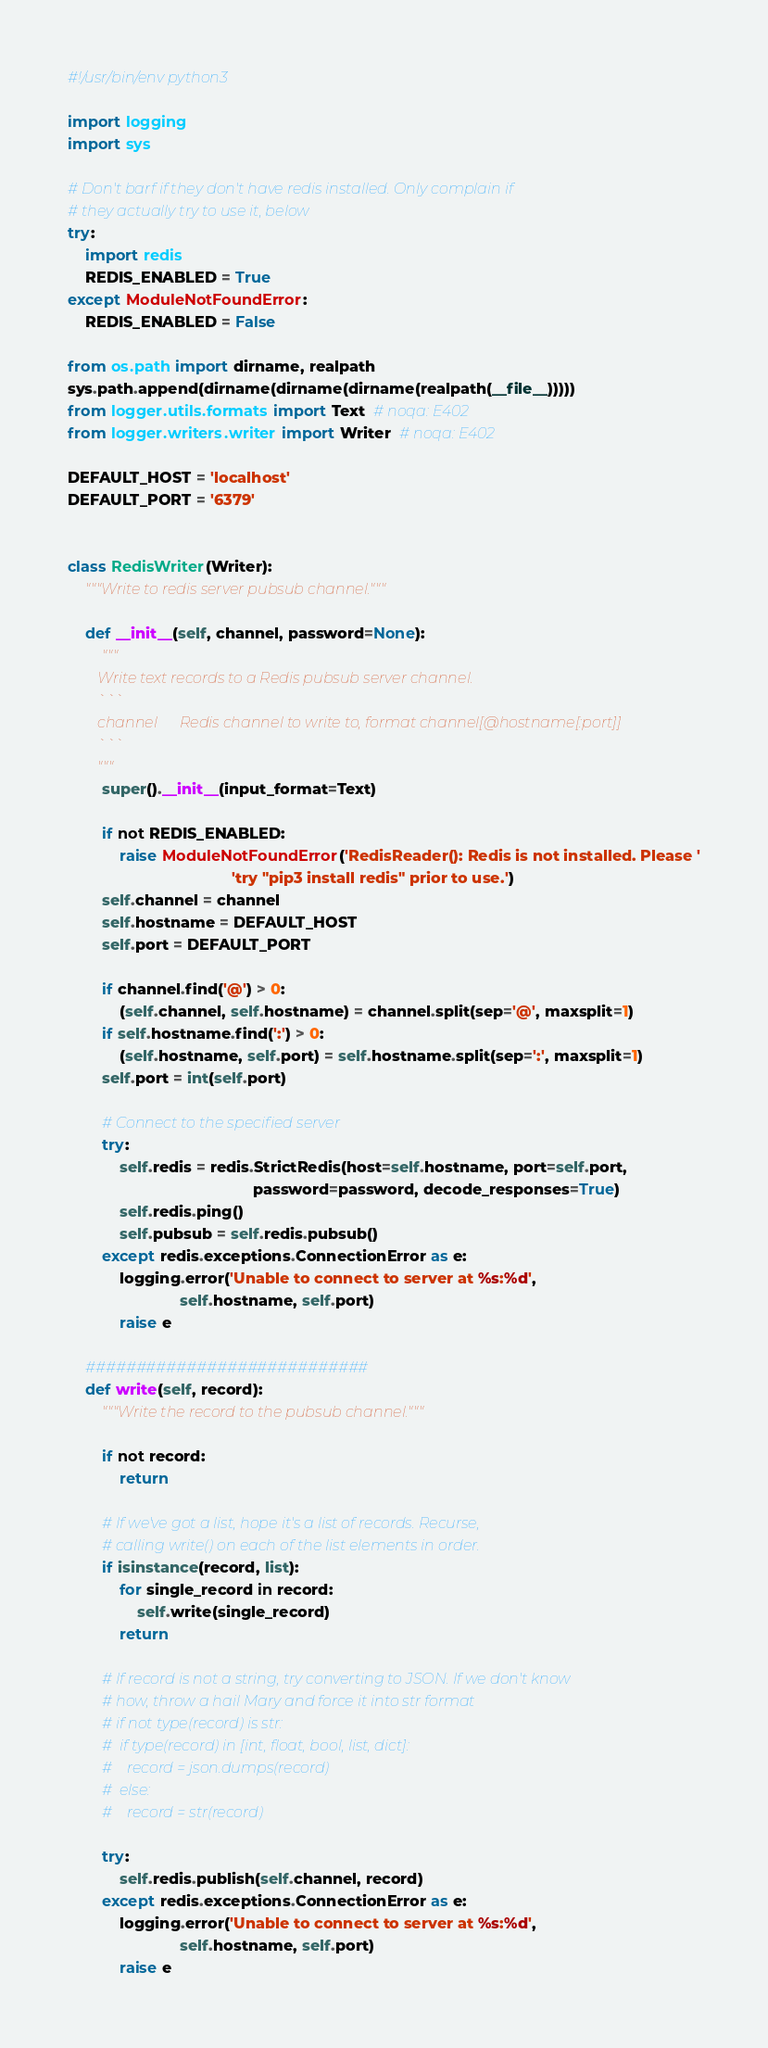<code> <loc_0><loc_0><loc_500><loc_500><_Python_>#!/usr/bin/env python3

import logging
import sys

# Don't barf if they don't have redis installed. Only complain if
# they actually try to use it, below
try:
    import redis
    REDIS_ENABLED = True
except ModuleNotFoundError:
    REDIS_ENABLED = False

from os.path import dirname, realpath
sys.path.append(dirname(dirname(dirname(realpath(__file__)))))
from logger.utils.formats import Text  # noqa: E402
from logger.writers.writer import Writer  # noqa: E402

DEFAULT_HOST = 'localhost'
DEFAULT_PORT = '6379'


class RedisWriter(Writer):
    """Write to redis server pubsub channel."""

    def __init__(self, channel, password=None):
        """
        Write text records to a Redis pubsub server channel.
        ```
        channel      Redis channel to write to, format channel[@hostname[:port]]
        ```
        """
        super().__init__(input_format=Text)

        if not REDIS_ENABLED:
            raise ModuleNotFoundError('RedisReader(): Redis is not installed. Please '
                                      'try "pip3 install redis" prior to use.')
        self.channel = channel
        self.hostname = DEFAULT_HOST
        self.port = DEFAULT_PORT

        if channel.find('@') > 0:
            (self.channel, self.hostname) = channel.split(sep='@', maxsplit=1)
        if self.hostname.find(':') > 0:
            (self.hostname, self.port) = self.hostname.split(sep=':', maxsplit=1)
        self.port = int(self.port)

        # Connect to the specified server
        try:
            self.redis = redis.StrictRedis(host=self.hostname, port=self.port,
                                           password=password, decode_responses=True)
            self.redis.ping()
            self.pubsub = self.redis.pubsub()
        except redis.exceptions.ConnectionError as e:
            logging.error('Unable to connect to server at %s:%d',
                          self.hostname, self.port)
            raise e

    ############################
    def write(self, record):
        """Write the record to the pubsub channel."""

        if not record:
            return

        # If we've got a list, hope it's a list of records. Recurse,
        # calling write() on each of the list elements in order.
        if isinstance(record, list):
            for single_record in record:
                self.write(single_record)
            return

        # If record is not a string, try converting to JSON. If we don't know
        # how, throw a hail Mary and force it into str format
        # if not type(record) is str:
        #  if type(record) in [int, float, bool, list, dict]:
        #    record = json.dumps(record)
        #  else:
        #    record = str(record)

        try:
            self.redis.publish(self.channel, record)
        except redis.exceptions.ConnectionError as e:
            logging.error('Unable to connect to server at %s:%d',
                          self.hostname, self.port)
            raise e
</code> 